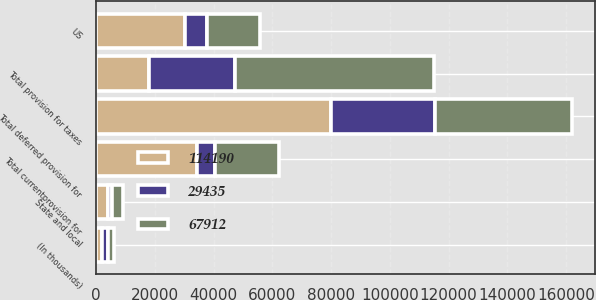Convert chart to OTSL. <chart><loc_0><loc_0><loc_500><loc_500><stacked_bar_chart><ecel><fcel>(In thousands)<fcel>US<fcel>State and local<fcel>Total currentprovision for<fcel>Total deferred provision for<fcel>Total provision for taxes<nl><fcel>29435<fcel>2002<fcel>7526<fcel>1298<fcel>6228<fcel>35663<fcel>29435<nl><fcel>67912<fcel>2001<fcel>17816<fcel>3742<fcel>21558<fcel>46354<fcel>67912<nl><fcel>114190<fcel>2000<fcel>30273<fcel>4074<fcel>34347<fcel>79843<fcel>17816<nl></chart> 